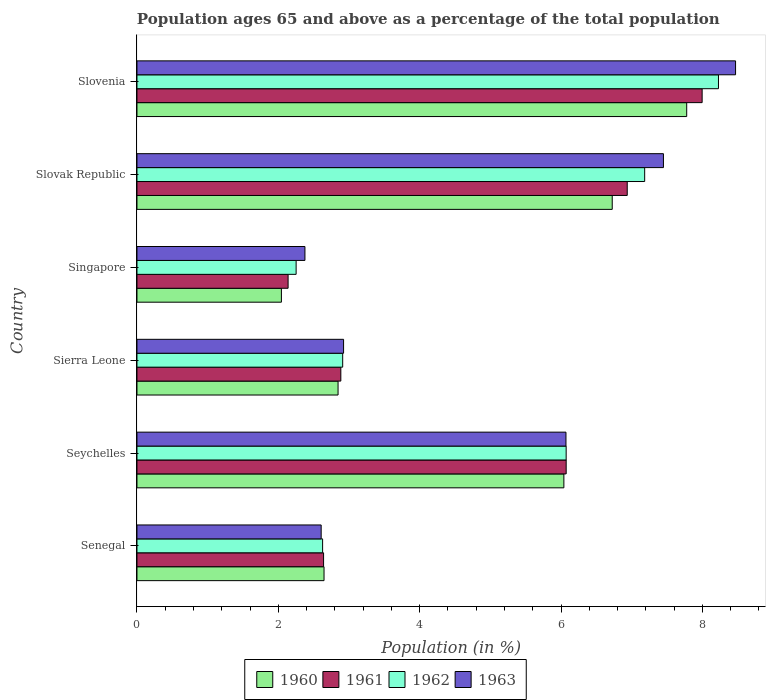How many different coloured bars are there?
Ensure brevity in your answer.  4. Are the number of bars per tick equal to the number of legend labels?
Give a very brief answer. Yes. Are the number of bars on each tick of the Y-axis equal?
Make the answer very short. Yes. How many bars are there on the 3rd tick from the top?
Provide a short and direct response. 4. How many bars are there on the 1st tick from the bottom?
Offer a very short reply. 4. What is the label of the 3rd group of bars from the top?
Make the answer very short. Singapore. In how many cases, is the number of bars for a given country not equal to the number of legend labels?
Offer a terse response. 0. What is the percentage of the population ages 65 and above in 1962 in Seychelles?
Provide a succinct answer. 6.07. Across all countries, what is the maximum percentage of the population ages 65 and above in 1963?
Keep it short and to the point. 8.47. Across all countries, what is the minimum percentage of the population ages 65 and above in 1961?
Your answer should be compact. 2.14. In which country was the percentage of the population ages 65 and above in 1961 maximum?
Give a very brief answer. Slovenia. In which country was the percentage of the population ages 65 and above in 1960 minimum?
Offer a terse response. Singapore. What is the total percentage of the population ages 65 and above in 1960 in the graph?
Provide a succinct answer. 28.08. What is the difference between the percentage of the population ages 65 and above in 1961 in Slovak Republic and that in Slovenia?
Offer a terse response. -1.06. What is the difference between the percentage of the population ages 65 and above in 1960 in Slovenia and the percentage of the population ages 65 and above in 1962 in Singapore?
Your answer should be very brief. 5.53. What is the average percentage of the population ages 65 and above in 1962 per country?
Your response must be concise. 4.88. What is the difference between the percentage of the population ages 65 and above in 1960 and percentage of the population ages 65 and above in 1962 in Slovenia?
Offer a terse response. -0.45. In how many countries, is the percentage of the population ages 65 and above in 1961 greater than 4 ?
Make the answer very short. 3. What is the ratio of the percentage of the population ages 65 and above in 1963 in Seychelles to that in Sierra Leone?
Keep it short and to the point. 2.08. Is the percentage of the population ages 65 and above in 1962 in Sierra Leone less than that in Singapore?
Your answer should be very brief. No. Is the difference between the percentage of the population ages 65 and above in 1960 in Singapore and Slovenia greater than the difference between the percentage of the population ages 65 and above in 1962 in Singapore and Slovenia?
Give a very brief answer. Yes. What is the difference between the highest and the second highest percentage of the population ages 65 and above in 1963?
Ensure brevity in your answer.  1.02. What is the difference between the highest and the lowest percentage of the population ages 65 and above in 1962?
Your answer should be compact. 5.98. What does the 4th bar from the bottom in Senegal represents?
Provide a short and direct response. 1963. How many countries are there in the graph?
Offer a very short reply. 6. What is the difference between two consecutive major ticks on the X-axis?
Make the answer very short. 2. Are the values on the major ticks of X-axis written in scientific E-notation?
Your answer should be very brief. No. Does the graph contain any zero values?
Your answer should be compact. No. Does the graph contain grids?
Provide a succinct answer. No. Where does the legend appear in the graph?
Offer a very short reply. Bottom center. How are the legend labels stacked?
Your response must be concise. Horizontal. What is the title of the graph?
Your response must be concise. Population ages 65 and above as a percentage of the total population. What is the label or title of the X-axis?
Offer a very short reply. Population (in %). What is the Population (in %) of 1960 in Senegal?
Give a very brief answer. 2.65. What is the Population (in %) in 1961 in Senegal?
Provide a short and direct response. 2.64. What is the Population (in %) in 1962 in Senegal?
Offer a terse response. 2.63. What is the Population (in %) of 1963 in Senegal?
Make the answer very short. 2.61. What is the Population (in %) in 1960 in Seychelles?
Keep it short and to the point. 6.04. What is the Population (in %) of 1961 in Seychelles?
Ensure brevity in your answer.  6.07. What is the Population (in %) of 1962 in Seychelles?
Offer a terse response. 6.07. What is the Population (in %) in 1963 in Seychelles?
Your answer should be compact. 6.07. What is the Population (in %) of 1960 in Sierra Leone?
Your answer should be very brief. 2.85. What is the Population (in %) of 1961 in Sierra Leone?
Provide a short and direct response. 2.88. What is the Population (in %) in 1962 in Sierra Leone?
Give a very brief answer. 2.91. What is the Population (in %) of 1963 in Sierra Leone?
Your answer should be compact. 2.92. What is the Population (in %) in 1960 in Singapore?
Provide a succinct answer. 2.04. What is the Population (in %) of 1961 in Singapore?
Provide a short and direct response. 2.14. What is the Population (in %) of 1962 in Singapore?
Your answer should be very brief. 2.25. What is the Population (in %) in 1963 in Singapore?
Ensure brevity in your answer.  2.38. What is the Population (in %) in 1960 in Slovak Republic?
Offer a very short reply. 6.72. What is the Population (in %) of 1961 in Slovak Republic?
Provide a short and direct response. 6.94. What is the Population (in %) of 1962 in Slovak Republic?
Provide a short and direct response. 7.18. What is the Population (in %) of 1963 in Slovak Republic?
Ensure brevity in your answer.  7.45. What is the Population (in %) of 1960 in Slovenia?
Your answer should be compact. 7.78. What is the Population (in %) of 1961 in Slovenia?
Keep it short and to the point. 8. What is the Population (in %) of 1962 in Slovenia?
Your response must be concise. 8.23. What is the Population (in %) in 1963 in Slovenia?
Your answer should be very brief. 8.47. Across all countries, what is the maximum Population (in %) of 1960?
Provide a short and direct response. 7.78. Across all countries, what is the maximum Population (in %) of 1961?
Give a very brief answer. 8. Across all countries, what is the maximum Population (in %) in 1962?
Your answer should be very brief. 8.23. Across all countries, what is the maximum Population (in %) of 1963?
Give a very brief answer. 8.47. Across all countries, what is the minimum Population (in %) of 1960?
Your answer should be compact. 2.04. Across all countries, what is the minimum Population (in %) of 1961?
Your response must be concise. 2.14. Across all countries, what is the minimum Population (in %) in 1962?
Keep it short and to the point. 2.25. Across all countries, what is the minimum Population (in %) of 1963?
Offer a very short reply. 2.38. What is the total Population (in %) of 1960 in the graph?
Ensure brevity in your answer.  28.08. What is the total Population (in %) in 1961 in the graph?
Make the answer very short. 28.67. What is the total Population (in %) in 1962 in the graph?
Your response must be concise. 29.27. What is the total Population (in %) of 1963 in the graph?
Ensure brevity in your answer.  29.89. What is the difference between the Population (in %) of 1960 in Senegal and that in Seychelles?
Offer a very short reply. -3.39. What is the difference between the Population (in %) of 1961 in Senegal and that in Seychelles?
Make the answer very short. -3.43. What is the difference between the Population (in %) of 1962 in Senegal and that in Seychelles?
Ensure brevity in your answer.  -3.45. What is the difference between the Population (in %) in 1963 in Senegal and that in Seychelles?
Give a very brief answer. -3.46. What is the difference between the Population (in %) in 1960 in Senegal and that in Sierra Leone?
Your answer should be compact. -0.2. What is the difference between the Population (in %) in 1961 in Senegal and that in Sierra Leone?
Give a very brief answer. -0.24. What is the difference between the Population (in %) of 1962 in Senegal and that in Sierra Leone?
Give a very brief answer. -0.28. What is the difference between the Population (in %) of 1963 in Senegal and that in Sierra Leone?
Keep it short and to the point. -0.32. What is the difference between the Population (in %) in 1960 in Senegal and that in Singapore?
Make the answer very short. 0.6. What is the difference between the Population (in %) of 1961 in Senegal and that in Singapore?
Keep it short and to the point. 0.5. What is the difference between the Population (in %) in 1962 in Senegal and that in Singapore?
Your answer should be compact. 0.37. What is the difference between the Population (in %) in 1963 in Senegal and that in Singapore?
Offer a very short reply. 0.23. What is the difference between the Population (in %) of 1960 in Senegal and that in Slovak Republic?
Provide a short and direct response. -4.08. What is the difference between the Population (in %) in 1961 in Senegal and that in Slovak Republic?
Provide a succinct answer. -4.3. What is the difference between the Population (in %) of 1962 in Senegal and that in Slovak Republic?
Make the answer very short. -4.56. What is the difference between the Population (in %) of 1963 in Senegal and that in Slovak Republic?
Your answer should be compact. -4.84. What is the difference between the Population (in %) of 1960 in Senegal and that in Slovenia?
Ensure brevity in your answer.  -5.13. What is the difference between the Population (in %) in 1961 in Senegal and that in Slovenia?
Keep it short and to the point. -5.36. What is the difference between the Population (in %) in 1962 in Senegal and that in Slovenia?
Offer a very short reply. -5.6. What is the difference between the Population (in %) in 1963 in Senegal and that in Slovenia?
Your answer should be compact. -5.86. What is the difference between the Population (in %) in 1960 in Seychelles and that in Sierra Leone?
Your answer should be compact. 3.19. What is the difference between the Population (in %) in 1961 in Seychelles and that in Sierra Leone?
Keep it short and to the point. 3.19. What is the difference between the Population (in %) in 1962 in Seychelles and that in Sierra Leone?
Your answer should be compact. 3.16. What is the difference between the Population (in %) of 1963 in Seychelles and that in Sierra Leone?
Give a very brief answer. 3.15. What is the difference between the Population (in %) in 1960 in Seychelles and that in Singapore?
Offer a very short reply. 4. What is the difference between the Population (in %) in 1961 in Seychelles and that in Singapore?
Keep it short and to the point. 3.93. What is the difference between the Population (in %) of 1962 in Seychelles and that in Singapore?
Make the answer very short. 3.82. What is the difference between the Population (in %) of 1963 in Seychelles and that in Singapore?
Your response must be concise. 3.69. What is the difference between the Population (in %) of 1960 in Seychelles and that in Slovak Republic?
Offer a very short reply. -0.68. What is the difference between the Population (in %) of 1961 in Seychelles and that in Slovak Republic?
Offer a terse response. -0.86. What is the difference between the Population (in %) of 1962 in Seychelles and that in Slovak Republic?
Offer a terse response. -1.11. What is the difference between the Population (in %) of 1963 in Seychelles and that in Slovak Republic?
Your answer should be very brief. -1.38. What is the difference between the Population (in %) in 1960 in Seychelles and that in Slovenia?
Your answer should be compact. -1.74. What is the difference between the Population (in %) in 1961 in Seychelles and that in Slovenia?
Offer a very short reply. -1.92. What is the difference between the Population (in %) in 1962 in Seychelles and that in Slovenia?
Give a very brief answer. -2.16. What is the difference between the Population (in %) of 1963 in Seychelles and that in Slovenia?
Provide a succinct answer. -2.4. What is the difference between the Population (in %) in 1960 in Sierra Leone and that in Singapore?
Provide a short and direct response. 0.8. What is the difference between the Population (in %) in 1961 in Sierra Leone and that in Singapore?
Ensure brevity in your answer.  0.75. What is the difference between the Population (in %) of 1962 in Sierra Leone and that in Singapore?
Keep it short and to the point. 0.66. What is the difference between the Population (in %) in 1963 in Sierra Leone and that in Singapore?
Provide a short and direct response. 0.55. What is the difference between the Population (in %) of 1960 in Sierra Leone and that in Slovak Republic?
Offer a terse response. -3.88. What is the difference between the Population (in %) in 1961 in Sierra Leone and that in Slovak Republic?
Your answer should be compact. -4.05. What is the difference between the Population (in %) of 1962 in Sierra Leone and that in Slovak Republic?
Offer a very short reply. -4.27. What is the difference between the Population (in %) in 1963 in Sierra Leone and that in Slovak Republic?
Offer a very short reply. -4.53. What is the difference between the Population (in %) of 1960 in Sierra Leone and that in Slovenia?
Your response must be concise. -4.93. What is the difference between the Population (in %) of 1961 in Sierra Leone and that in Slovenia?
Offer a very short reply. -5.11. What is the difference between the Population (in %) of 1962 in Sierra Leone and that in Slovenia?
Give a very brief answer. -5.32. What is the difference between the Population (in %) in 1963 in Sierra Leone and that in Slovenia?
Provide a short and direct response. -5.55. What is the difference between the Population (in %) in 1960 in Singapore and that in Slovak Republic?
Your answer should be very brief. -4.68. What is the difference between the Population (in %) of 1961 in Singapore and that in Slovak Republic?
Ensure brevity in your answer.  -4.8. What is the difference between the Population (in %) in 1962 in Singapore and that in Slovak Republic?
Make the answer very short. -4.93. What is the difference between the Population (in %) of 1963 in Singapore and that in Slovak Republic?
Ensure brevity in your answer.  -5.07. What is the difference between the Population (in %) in 1960 in Singapore and that in Slovenia?
Provide a succinct answer. -5.73. What is the difference between the Population (in %) in 1961 in Singapore and that in Slovenia?
Your answer should be compact. -5.86. What is the difference between the Population (in %) in 1962 in Singapore and that in Slovenia?
Keep it short and to the point. -5.98. What is the difference between the Population (in %) in 1963 in Singapore and that in Slovenia?
Ensure brevity in your answer.  -6.09. What is the difference between the Population (in %) in 1960 in Slovak Republic and that in Slovenia?
Ensure brevity in your answer.  -1.05. What is the difference between the Population (in %) in 1961 in Slovak Republic and that in Slovenia?
Give a very brief answer. -1.06. What is the difference between the Population (in %) in 1962 in Slovak Republic and that in Slovenia?
Give a very brief answer. -1.04. What is the difference between the Population (in %) in 1963 in Slovak Republic and that in Slovenia?
Make the answer very short. -1.02. What is the difference between the Population (in %) of 1960 in Senegal and the Population (in %) of 1961 in Seychelles?
Keep it short and to the point. -3.43. What is the difference between the Population (in %) in 1960 in Senegal and the Population (in %) in 1962 in Seychelles?
Give a very brief answer. -3.43. What is the difference between the Population (in %) of 1960 in Senegal and the Population (in %) of 1963 in Seychelles?
Ensure brevity in your answer.  -3.42. What is the difference between the Population (in %) in 1961 in Senegal and the Population (in %) in 1962 in Seychelles?
Your response must be concise. -3.43. What is the difference between the Population (in %) of 1961 in Senegal and the Population (in %) of 1963 in Seychelles?
Your response must be concise. -3.43. What is the difference between the Population (in %) of 1962 in Senegal and the Population (in %) of 1963 in Seychelles?
Give a very brief answer. -3.44. What is the difference between the Population (in %) in 1960 in Senegal and the Population (in %) in 1961 in Sierra Leone?
Your response must be concise. -0.24. What is the difference between the Population (in %) in 1960 in Senegal and the Population (in %) in 1962 in Sierra Leone?
Give a very brief answer. -0.26. What is the difference between the Population (in %) in 1960 in Senegal and the Population (in %) in 1963 in Sierra Leone?
Offer a terse response. -0.28. What is the difference between the Population (in %) of 1961 in Senegal and the Population (in %) of 1962 in Sierra Leone?
Your answer should be very brief. -0.27. What is the difference between the Population (in %) of 1961 in Senegal and the Population (in %) of 1963 in Sierra Leone?
Give a very brief answer. -0.28. What is the difference between the Population (in %) of 1962 in Senegal and the Population (in %) of 1963 in Sierra Leone?
Give a very brief answer. -0.3. What is the difference between the Population (in %) in 1960 in Senegal and the Population (in %) in 1961 in Singapore?
Your answer should be compact. 0.51. What is the difference between the Population (in %) in 1960 in Senegal and the Population (in %) in 1962 in Singapore?
Your answer should be compact. 0.4. What is the difference between the Population (in %) of 1960 in Senegal and the Population (in %) of 1963 in Singapore?
Keep it short and to the point. 0.27. What is the difference between the Population (in %) in 1961 in Senegal and the Population (in %) in 1962 in Singapore?
Make the answer very short. 0.39. What is the difference between the Population (in %) in 1961 in Senegal and the Population (in %) in 1963 in Singapore?
Give a very brief answer. 0.26. What is the difference between the Population (in %) of 1962 in Senegal and the Population (in %) of 1963 in Singapore?
Make the answer very short. 0.25. What is the difference between the Population (in %) in 1960 in Senegal and the Population (in %) in 1961 in Slovak Republic?
Your answer should be very brief. -4.29. What is the difference between the Population (in %) in 1960 in Senegal and the Population (in %) in 1962 in Slovak Republic?
Your answer should be compact. -4.54. What is the difference between the Population (in %) of 1960 in Senegal and the Population (in %) of 1963 in Slovak Republic?
Keep it short and to the point. -4.8. What is the difference between the Population (in %) of 1961 in Senegal and the Population (in %) of 1962 in Slovak Republic?
Offer a terse response. -4.54. What is the difference between the Population (in %) in 1961 in Senegal and the Population (in %) in 1963 in Slovak Republic?
Make the answer very short. -4.81. What is the difference between the Population (in %) of 1962 in Senegal and the Population (in %) of 1963 in Slovak Republic?
Your answer should be very brief. -4.82. What is the difference between the Population (in %) of 1960 in Senegal and the Population (in %) of 1961 in Slovenia?
Keep it short and to the point. -5.35. What is the difference between the Population (in %) in 1960 in Senegal and the Population (in %) in 1962 in Slovenia?
Your answer should be compact. -5.58. What is the difference between the Population (in %) of 1960 in Senegal and the Population (in %) of 1963 in Slovenia?
Your answer should be compact. -5.82. What is the difference between the Population (in %) in 1961 in Senegal and the Population (in %) in 1962 in Slovenia?
Provide a succinct answer. -5.59. What is the difference between the Population (in %) of 1961 in Senegal and the Population (in %) of 1963 in Slovenia?
Make the answer very short. -5.83. What is the difference between the Population (in %) of 1962 in Senegal and the Population (in %) of 1963 in Slovenia?
Make the answer very short. -5.84. What is the difference between the Population (in %) in 1960 in Seychelles and the Population (in %) in 1961 in Sierra Leone?
Offer a terse response. 3.16. What is the difference between the Population (in %) of 1960 in Seychelles and the Population (in %) of 1962 in Sierra Leone?
Your response must be concise. 3.13. What is the difference between the Population (in %) in 1960 in Seychelles and the Population (in %) in 1963 in Sierra Leone?
Your response must be concise. 3.12. What is the difference between the Population (in %) of 1961 in Seychelles and the Population (in %) of 1962 in Sierra Leone?
Offer a terse response. 3.16. What is the difference between the Population (in %) in 1961 in Seychelles and the Population (in %) in 1963 in Sierra Leone?
Your answer should be very brief. 3.15. What is the difference between the Population (in %) in 1962 in Seychelles and the Population (in %) in 1963 in Sierra Leone?
Give a very brief answer. 3.15. What is the difference between the Population (in %) in 1960 in Seychelles and the Population (in %) in 1961 in Singapore?
Offer a very short reply. 3.9. What is the difference between the Population (in %) of 1960 in Seychelles and the Population (in %) of 1962 in Singapore?
Your answer should be very brief. 3.79. What is the difference between the Population (in %) of 1960 in Seychelles and the Population (in %) of 1963 in Singapore?
Provide a short and direct response. 3.66. What is the difference between the Population (in %) of 1961 in Seychelles and the Population (in %) of 1962 in Singapore?
Ensure brevity in your answer.  3.82. What is the difference between the Population (in %) in 1961 in Seychelles and the Population (in %) in 1963 in Singapore?
Keep it short and to the point. 3.7. What is the difference between the Population (in %) of 1962 in Seychelles and the Population (in %) of 1963 in Singapore?
Offer a very short reply. 3.7. What is the difference between the Population (in %) of 1960 in Seychelles and the Population (in %) of 1961 in Slovak Republic?
Keep it short and to the point. -0.9. What is the difference between the Population (in %) in 1960 in Seychelles and the Population (in %) in 1962 in Slovak Republic?
Provide a succinct answer. -1.14. What is the difference between the Population (in %) of 1960 in Seychelles and the Population (in %) of 1963 in Slovak Republic?
Keep it short and to the point. -1.41. What is the difference between the Population (in %) in 1961 in Seychelles and the Population (in %) in 1962 in Slovak Republic?
Offer a terse response. -1.11. What is the difference between the Population (in %) of 1961 in Seychelles and the Population (in %) of 1963 in Slovak Republic?
Make the answer very short. -1.38. What is the difference between the Population (in %) of 1962 in Seychelles and the Population (in %) of 1963 in Slovak Republic?
Your response must be concise. -1.38. What is the difference between the Population (in %) of 1960 in Seychelles and the Population (in %) of 1961 in Slovenia?
Make the answer very short. -1.96. What is the difference between the Population (in %) in 1960 in Seychelles and the Population (in %) in 1962 in Slovenia?
Your answer should be compact. -2.19. What is the difference between the Population (in %) in 1960 in Seychelles and the Population (in %) in 1963 in Slovenia?
Your answer should be very brief. -2.43. What is the difference between the Population (in %) in 1961 in Seychelles and the Population (in %) in 1962 in Slovenia?
Keep it short and to the point. -2.15. What is the difference between the Population (in %) of 1961 in Seychelles and the Population (in %) of 1963 in Slovenia?
Your answer should be very brief. -2.4. What is the difference between the Population (in %) of 1962 in Seychelles and the Population (in %) of 1963 in Slovenia?
Provide a short and direct response. -2.4. What is the difference between the Population (in %) in 1960 in Sierra Leone and the Population (in %) in 1961 in Singapore?
Provide a succinct answer. 0.71. What is the difference between the Population (in %) of 1960 in Sierra Leone and the Population (in %) of 1962 in Singapore?
Your answer should be compact. 0.59. What is the difference between the Population (in %) in 1960 in Sierra Leone and the Population (in %) in 1963 in Singapore?
Offer a very short reply. 0.47. What is the difference between the Population (in %) in 1961 in Sierra Leone and the Population (in %) in 1962 in Singapore?
Your answer should be very brief. 0.63. What is the difference between the Population (in %) in 1961 in Sierra Leone and the Population (in %) in 1963 in Singapore?
Keep it short and to the point. 0.51. What is the difference between the Population (in %) of 1962 in Sierra Leone and the Population (in %) of 1963 in Singapore?
Your answer should be compact. 0.53. What is the difference between the Population (in %) in 1960 in Sierra Leone and the Population (in %) in 1961 in Slovak Republic?
Your response must be concise. -4.09. What is the difference between the Population (in %) in 1960 in Sierra Leone and the Population (in %) in 1962 in Slovak Republic?
Give a very brief answer. -4.34. What is the difference between the Population (in %) of 1960 in Sierra Leone and the Population (in %) of 1963 in Slovak Republic?
Offer a very short reply. -4.6. What is the difference between the Population (in %) of 1961 in Sierra Leone and the Population (in %) of 1962 in Slovak Republic?
Provide a succinct answer. -4.3. What is the difference between the Population (in %) of 1961 in Sierra Leone and the Population (in %) of 1963 in Slovak Republic?
Your response must be concise. -4.56. What is the difference between the Population (in %) in 1962 in Sierra Leone and the Population (in %) in 1963 in Slovak Republic?
Ensure brevity in your answer.  -4.54. What is the difference between the Population (in %) in 1960 in Sierra Leone and the Population (in %) in 1961 in Slovenia?
Offer a very short reply. -5.15. What is the difference between the Population (in %) in 1960 in Sierra Leone and the Population (in %) in 1962 in Slovenia?
Your response must be concise. -5.38. What is the difference between the Population (in %) of 1960 in Sierra Leone and the Population (in %) of 1963 in Slovenia?
Offer a very short reply. -5.62. What is the difference between the Population (in %) in 1961 in Sierra Leone and the Population (in %) in 1962 in Slovenia?
Provide a succinct answer. -5.34. What is the difference between the Population (in %) of 1961 in Sierra Leone and the Population (in %) of 1963 in Slovenia?
Provide a succinct answer. -5.58. What is the difference between the Population (in %) in 1962 in Sierra Leone and the Population (in %) in 1963 in Slovenia?
Provide a short and direct response. -5.56. What is the difference between the Population (in %) of 1960 in Singapore and the Population (in %) of 1961 in Slovak Republic?
Give a very brief answer. -4.89. What is the difference between the Population (in %) in 1960 in Singapore and the Population (in %) in 1962 in Slovak Republic?
Your answer should be compact. -5.14. What is the difference between the Population (in %) in 1960 in Singapore and the Population (in %) in 1963 in Slovak Republic?
Your answer should be compact. -5.41. What is the difference between the Population (in %) of 1961 in Singapore and the Population (in %) of 1962 in Slovak Republic?
Provide a succinct answer. -5.05. What is the difference between the Population (in %) in 1961 in Singapore and the Population (in %) in 1963 in Slovak Republic?
Make the answer very short. -5.31. What is the difference between the Population (in %) of 1962 in Singapore and the Population (in %) of 1963 in Slovak Republic?
Offer a terse response. -5.2. What is the difference between the Population (in %) of 1960 in Singapore and the Population (in %) of 1961 in Slovenia?
Make the answer very short. -5.95. What is the difference between the Population (in %) of 1960 in Singapore and the Population (in %) of 1962 in Slovenia?
Provide a succinct answer. -6.18. What is the difference between the Population (in %) in 1960 in Singapore and the Population (in %) in 1963 in Slovenia?
Your answer should be compact. -6.43. What is the difference between the Population (in %) of 1961 in Singapore and the Population (in %) of 1962 in Slovenia?
Offer a very short reply. -6.09. What is the difference between the Population (in %) in 1961 in Singapore and the Population (in %) in 1963 in Slovenia?
Give a very brief answer. -6.33. What is the difference between the Population (in %) in 1962 in Singapore and the Population (in %) in 1963 in Slovenia?
Offer a very short reply. -6.22. What is the difference between the Population (in %) in 1960 in Slovak Republic and the Population (in %) in 1961 in Slovenia?
Keep it short and to the point. -1.27. What is the difference between the Population (in %) in 1960 in Slovak Republic and the Population (in %) in 1962 in Slovenia?
Offer a terse response. -1.5. What is the difference between the Population (in %) of 1960 in Slovak Republic and the Population (in %) of 1963 in Slovenia?
Offer a very short reply. -1.74. What is the difference between the Population (in %) in 1961 in Slovak Republic and the Population (in %) in 1962 in Slovenia?
Offer a terse response. -1.29. What is the difference between the Population (in %) of 1961 in Slovak Republic and the Population (in %) of 1963 in Slovenia?
Give a very brief answer. -1.53. What is the difference between the Population (in %) in 1962 in Slovak Republic and the Population (in %) in 1963 in Slovenia?
Make the answer very short. -1.29. What is the average Population (in %) of 1960 per country?
Keep it short and to the point. 4.68. What is the average Population (in %) in 1961 per country?
Provide a short and direct response. 4.78. What is the average Population (in %) of 1962 per country?
Your answer should be very brief. 4.88. What is the average Population (in %) in 1963 per country?
Make the answer very short. 4.98. What is the difference between the Population (in %) of 1960 and Population (in %) of 1961 in Senegal?
Give a very brief answer. 0.01. What is the difference between the Population (in %) of 1960 and Population (in %) of 1962 in Senegal?
Offer a very short reply. 0.02. What is the difference between the Population (in %) in 1960 and Population (in %) in 1963 in Senegal?
Offer a terse response. 0.04. What is the difference between the Population (in %) of 1961 and Population (in %) of 1962 in Senegal?
Give a very brief answer. 0.01. What is the difference between the Population (in %) of 1961 and Population (in %) of 1963 in Senegal?
Your answer should be compact. 0.03. What is the difference between the Population (in %) in 1962 and Population (in %) in 1963 in Senegal?
Your answer should be very brief. 0.02. What is the difference between the Population (in %) of 1960 and Population (in %) of 1961 in Seychelles?
Ensure brevity in your answer.  -0.03. What is the difference between the Population (in %) of 1960 and Population (in %) of 1962 in Seychelles?
Offer a terse response. -0.03. What is the difference between the Population (in %) of 1960 and Population (in %) of 1963 in Seychelles?
Offer a terse response. -0.03. What is the difference between the Population (in %) of 1961 and Population (in %) of 1963 in Seychelles?
Offer a very short reply. 0. What is the difference between the Population (in %) of 1962 and Population (in %) of 1963 in Seychelles?
Keep it short and to the point. 0. What is the difference between the Population (in %) in 1960 and Population (in %) in 1961 in Sierra Leone?
Your answer should be compact. -0.04. What is the difference between the Population (in %) of 1960 and Population (in %) of 1962 in Sierra Leone?
Your answer should be compact. -0.07. What is the difference between the Population (in %) in 1960 and Population (in %) in 1963 in Sierra Leone?
Ensure brevity in your answer.  -0.08. What is the difference between the Population (in %) in 1961 and Population (in %) in 1962 in Sierra Leone?
Give a very brief answer. -0.03. What is the difference between the Population (in %) of 1961 and Population (in %) of 1963 in Sierra Leone?
Your answer should be compact. -0.04. What is the difference between the Population (in %) in 1962 and Population (in %) in 1963 in Sierra Leone?
Provide a short and direct response. -0.01. What is the difference between the Population (in %) of 1960 and Population (in %) of 1961 in Singapore?
Your response must be concise. -0.09. What is the difference between the Population (in %) in 1960 and Population (in %) in 1962 in Singapore?
Give a very brief answer. -0.21. What is the difference between the Population (in %) in 1960 and Population (in %) in 1963 in Singapore?
Ensure brevity in your answer.  -0.33. What is the difference between the Population (in %) in 1961 and Population (in %) in 1962 in Singapore?
Your answer should be compact. -0.11. What is the difference between the Population (in %) in 1961 and Population (in %) in 1963 in Singapore?
Provide a succinct answer. -0.24. What is the difference between the Population (in %) in 1962 and Population (in %) in 1963 in Singapore?
Make the answer very short. -0.12. What is the difference between the Population (in %) in 1960 and Population (in %) in 1961 in Slovak Republic?
Provide a short and direct response. -0.21. What is the difference between the Population (in %) of 1960 and Population (in %) of 1962 in Slovak Republic?
Ensure brevity in your answer.  -0.46. What is the difference between the Population (in %) of 1960 and Population (in %) of 1963 in Slovak Republic?
Ensure brevity in your answer.  -0.72. What is the difference between the Population (in %) of 1961 and Population (in %) of 1962 in Slovak Republic?
Your answer should be compact. -0.25. What is the difference between the Population (in %) of 1961 and Population (in %) of 1963 in Slovak Republic?
Provide a succinct answer. -0.51. What is the difference between the Population (in %) of 1962 and Population (in %) of 1963 in Slovak Republic?
Keep it short and to the point. -0.27. What is the difference between the Population (in %) of 1960 and Population (in %) of 1961 in Slovenia?
Provide a succinct answer. -0.22. What is the difference between the Population (in %) of 1960 and Population (in %) of 1962 in Slovenia?
Offer a very short reply. -0.45. What is the difference between the Population (in %) of 1960 and Population (in %) of 1963 in Slovenia?
Offer a very short reply. -0.69. What is the difference between the Population (in %) in 1961 and Population (in %) in 1962 in Slovenia?
Give a very brief answer. -0.23. What is the difference between the Population (in %) of 1961 and Population (in %) of 1963 in Slovenia?
Offer a very short reply. -0.47. What is the difference between the Population (in %) of 1962 and Population (in %) of 1963 in Slovenia?
Offer a terse response. -0.24. What is the ratio of the Population (in %) in 1960 in Senegal to that in Seychelles?
Offer a very short reply. 0.44. What is the ratio of the Population (in %) of 1961 in Senegal to that in Seychelles?
Give a very brief answer. 0.43. What is the ratio of the Population (in %) of 1962 in Senegal to that in Seychelles?
Provide a succinct answer. 0.43. What is the ratio of the Population (in %) in 1963 in Senegal to that in Seychelles?
Make the answer very short. 0.43. What is the ratio of the Population (in %) of 1960 in Senegal to that in Sierra Leone?
Your response must be concise. 0.93. What is the ratio of the Population (in %) in 1961 in Senegal to that in Sierra Leone?
Make the answer very short. 0.92. What is the ratio of the Population (in %) of 1962 in Senegal to that in Sierra Leone?
Make the answer very short. 0.9. What is the ratio of the Population (in %) of 1963 in Senegal to that in Sierra Leone?
Keep it short and to the point. 0.89. What is the ratio of the Population (in %) of 1960 in Senegal to that in Singapore?
Make the answer very short. 1.3. What is the ratio of the Population (in %) in 1961 in Senegal to that in Singapore?
Provide a succinct answer. 1.23. What is the ratio of the Population (in %) of 1962 in Senegal to that in Singapore?
Give a very brief answer. 1.17. What is the ratio of the Population (in %) of 1963 in Senegal to that in Singapore?
Offer a terse response. 1.1. What is the ratio of the Population (in %) in 1960 in Senegal to that in Slovak Republic?
Your response must be concise. 0.39. What is the ratio of the Population (in %) of 1961 in Senegal to that in Slovak Republic?
Give a very brief answer. 0.38. What is the ratio of the Population (in %) in 1962 in Senegal to that in Slovak Republic?
Provide a short and direct response. 0.37. What is the ratio of the Population (in %) in 1963 in Senegal to that in Slovak Republic?
Give a very brief answer. 0.35. What is the ratio of the Population (in %) of 1960 in Senegal to that in Slovenia?
Ensure brevity in your answer.  0.34. What is the ratio of the Population (in %) of 1961 in Senegal to that in Slovenia?
Provide a short and direct response. 0.33. What is the ratio of the Population (in %) of 1962 in Senegal to that in Slovenia?
Keep it short and to the point. 0.32. What is the ratio of the Population (in %) of 1963 in Senegal to that in Slovenia?
Provide a short and direct response. 0.31. What is the ratio of the Population (in %) in 1960 in Seychelles to that in Sierra Leone?
Your answer should be compact. 2.12. What is the ratio of the Population (in %) in 1961 in Seychelles to that in Sierra Leone?
Keep it short and to the point. 2.11. What is the ratio of the Population (in %) in 1962 in Seychelles to that in Sierra Leone?
Provide a succinct answer. 2.09. What is the ratio of the Population (in %) in 1963 in Seychelles to that in Sierra Leone?
Provide a short and direct response. 2.08. What is the ratio of the Population (in %) in 1960 in Seychelles to that in Singapore?
Give a very brief answer. 2.96. What is the ratio of the Population (in %) of 1961 in Seychelles to that in Singapore?
Your answer should be compact. 2.84. What is the ratio of the Population (in %) of 1962 in Seychelles to that in Singapore?
Your answer should be compact. 2.7. What is the ratio of the Population (in %) in 1963 in Seychelles to that in Singapore?
Give a very brief answer. 2.55. What is the ratio of the Population (in %) in 1960 in Seychelles to that in Slovak Republic?
Offer a terse response. 0.9. What is the ratio of the Population (in %) of 1961 in Seychelles to that in Slovak Republic?
Ensure brevity in your answer.  0.88. What is the ratio of the Population (in %) of 1962 in Seychelles to that in Slovak Republic?
Your answer should be compact. 0.85. What is the ratio of the Population (in %) in 1963 in Seychelles to that in Slovak Republic?
Make the answer very short. 0.81. What is the ratio of the Population (in %) in 1960 in Seychelles to that in Slovenia?
Provide a succinct answer. 0.78. What is the ratio of the Population (in %) in 1961 in Seychelles to that in Slovenia?
Offer a very short reply. 0.76. What is the ratio of the Population (in %) of 1962 in Seychelles to that in Slovenia?
Ensure brevity in your answer.  0.74. What is the ratio of the Population (in %) in 1963 in Seychelles to that in Slovenia?
Your answer should be very brief. 0.72. What is the ratio of the Population (in %) of 1960 in Sierra Leone to that in Singapore?
Offer a very short reply. 1.39. What is the ratio of the Population (in %) in 1961 in Sierra Leone to that in Singapore?
Make the answer very short. 1.35. What is the ratio of the Population (in %) of 1962 in Sierra Leone to that in Singapore?
Your answer should be compact. 1.29. What is the ratio of the Population (in %) in 1963 in Sierra Leone to that in Singapore?
Your answer should be very brief. 1.23. What is the ratio of the Population (in %) of 1960 in Sierra Leone to that in Slovak Republic?
Offer a terse response. 0.42. What is the ratio of the Population (in %) of 1961 in Sierra Leone to that in Slovak Republic?
Your response must be concise. 0.42. What is the ratio of the Population (in %) in 1962 in Sierra Leone to that in Slovak Republic?
Your answer should be very brief. 0.41. What is the ratio of the Population (in %) in 1963 in Sierra Leone to that in Slovak Republic?
Make the answer very short. 0.39. What is the ratio of the Population (in %) of 1960 in Sierra Leone to that in Slovenia?
Offer a very short reply. 0.37. What is the ratio of the Population (in %) of 1961 in Sierra Leone to that in Slovenia?
Provide a succinct answer. 0.36. What is the ratio of the Population (in %) in 1962 in Sierra Leone to that in Slovenia?
Provide a short and direct response. 0.35. What is the ratio of the Population (in %) in 1963 in Sierra Leone to that in Slovenia?
Your answer should be compact. 0.35. What is the ratio of the Population (in %) of 1960 in Singapore to that in Slovak Republic?
Provide a succinct answer. 0.3. What is the ratio of the Population (in %) in 1961 in Singapore to that in Slovak Republic?
Provide a succinct answer. 0.31. What is the ratio of the Population (in %) in 1962 in Singapore to that in Slovak Republic?
Offer a very short reply. 0.31. What is the ratio of the Population (in %) of 1963 in Singapore to that in Slovak Republic?
Offer a very short reply. 0.32. What is the ratio of the Population (in %) of 1960 in Singapore to that in Slovenia?
Give a very brief answer. 0.26. What is the ratio of the Population (in %) of 1961 in Singapore to that in Slovenia?
Ensure brevity in your answer.  0.27. What is the ratio of the Population (in %) of 1962 in Singapore to that in Slovenia?
Keep it short and to the point. 0.27. What is the ratio of the Population (in %) of 1963 in Singapore to that in Slovenia?
Offer a terse response. 0.28. What is the ratio of the Population (in %) in 1960 in Slovak Republic to that in Slovenia?
Provide a succinct answer. 0.86. What is the ratio of the Population (in %) in 1961 in Slovak Republic to that in Slovenia?
Give a very brief answer. 0.87. What is the ratio of the Population (in %) in 1962 in Slovak Republic to that in Slovenia?
Provide a succinct answer. 0.87. What is the ratio of the Population (in %) in 1963 in Slovak Republic to that in Slovenia?
Your response must be concise. 0.88. What is the difference between the highest and the second highest Population (in %) in 1960?
Keep it short and to the point. 1.05. What is the difference between the highest and the second highest Population (in %) in 1961?
Offer a very short reply. 1.06. What is the difference between the highest and the second highest Population (in %) of 1962?
Offer a terse response. 1.04. What is the difference between the highest and the second highest Population (in %) of 1963?
Your response must be concise. 1.02. What is the difference between the highest and the lowest Population (in %) of 1960?
Offer a very short reply. 5.73. What is the difference between the highest and the lowest Population (in %) in 1961?
Ensure brevity in your answer.  5.86. What is the difference between the highest and the lowest Population (in %) in 1962?
Ensure brevity in your answer.  5.98. What is the difference between the highest and the lowest Population (in %) of 1963?
Ensure brevity in your answer.  6.09. 